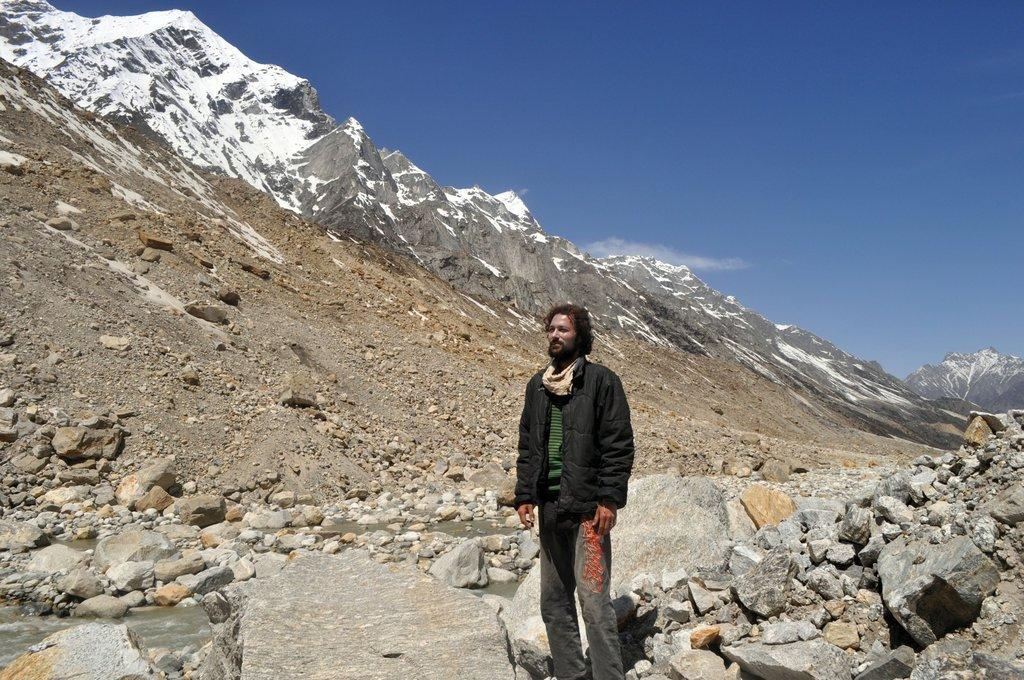What type of natural formation can be seen in the image? There are hills in the image. What other objects or features are present in the image? There are rocks in the image. Can you describe the person in the image? There is a person wearing a black jacket in the image. What is visible at the top of the image? The sky is visible at the top of the image. What color is the vein running through the metal in the image? There is no metal or vein present in the image; it features hills, rocks, and a person wearing a black jacket. 